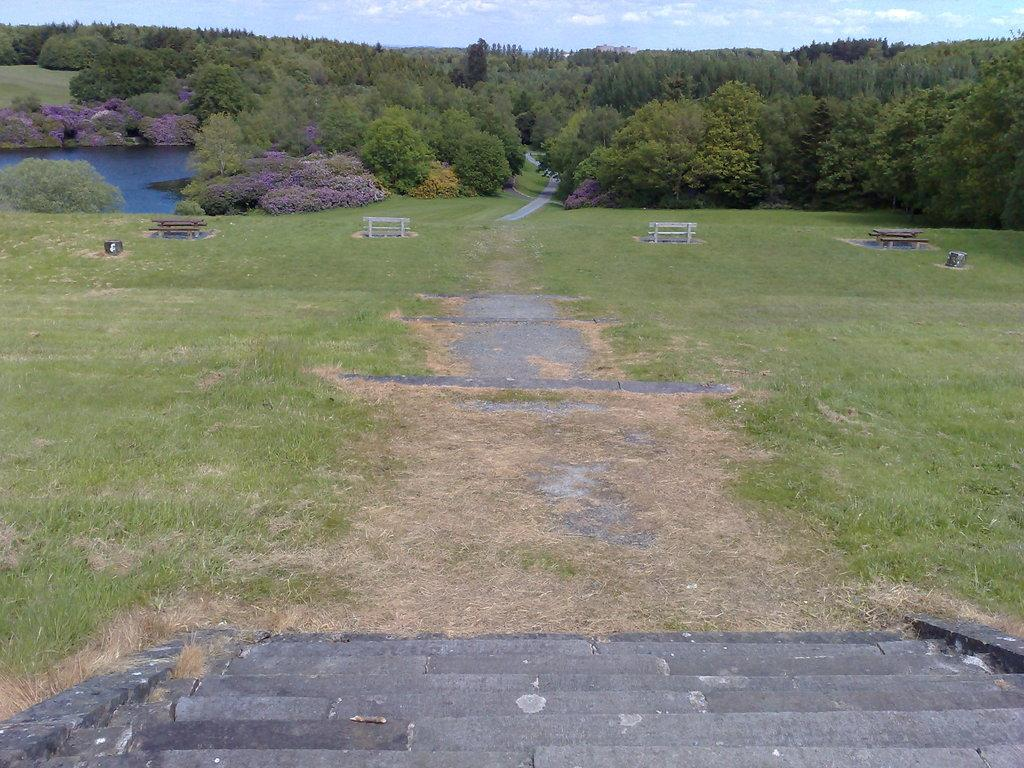What type of structure can be seen in the image? There are stairs in the image. What is the ground surface like in the image? The ground is covered with grass. What type of seating is available in the image? There are benches on the ground. What natural element is visible in the image? There is water visible in the image. What type of vegetation is present in the image? Trees and plants are visible in the image. What part of the natural environment is visible in the image? The sky is visible in the image. What atmospheric feature can be seen in the sky? Clouds are present in the sky. Can you tell me how many lawyers are attending to the plants in the image? There are no lawyers present in the image, and therefore no such activity can be observed. 